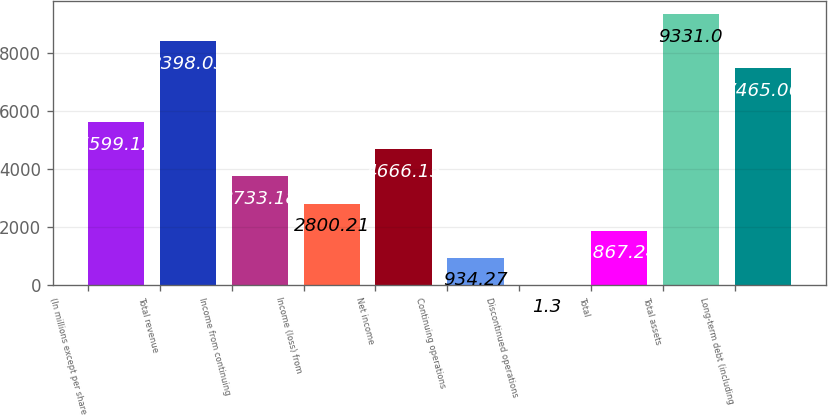<chart> <loc_0><loc_0><loc_500><loc_500><bar_chart><fcel>(In millions except per share<fcel>Total revenue<fcel>Income from continuing<fcel>Income (loss) from<fcel>Net income<fcel>Continuing operations<fcel>Discontinued operations<fcel>Total<fcel>Total assets<fcel>Long-term debt (including<nl><fcel>5599.12<fcel>8398.03<fcel>3733.18<fcel>2800.21<fcel>4666.15<fcel>934.27<fcel>1.3<fcel>1867.24<fcel>9331<fcel>7465.06<nl></chart> 